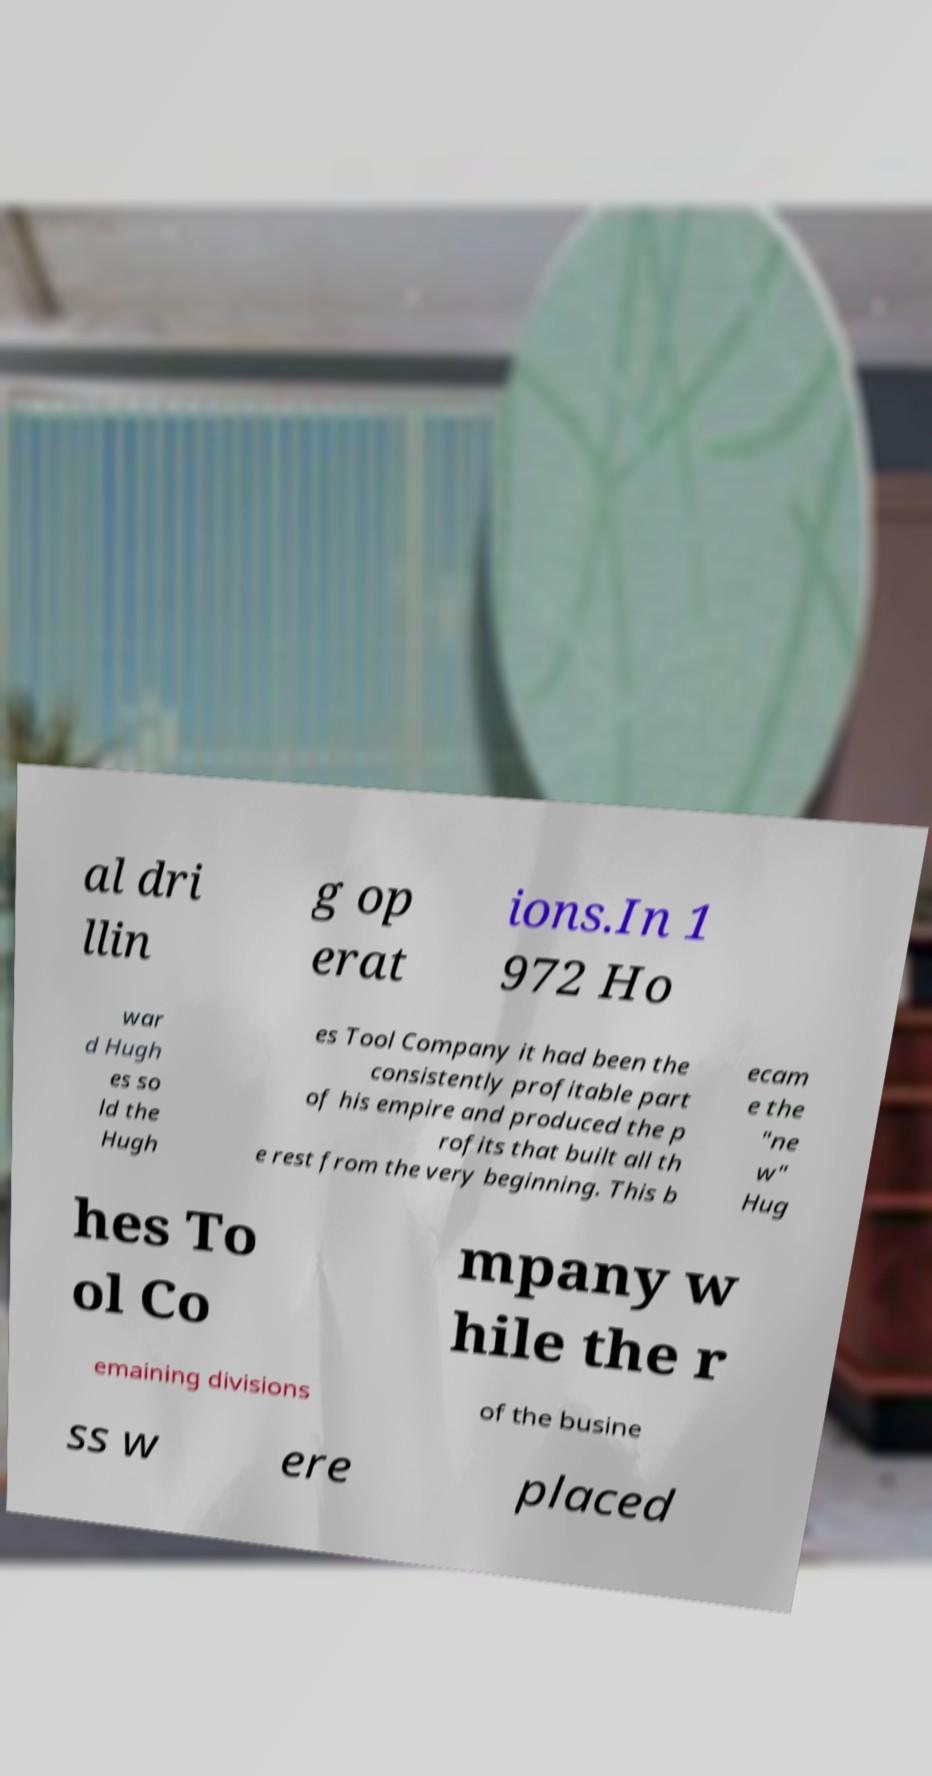Please read and relay the text visible in this image. What does it say? al dri llin g op erat ions.In 1 972 Ho war d Hugh es so ld the Hugh es Tool Company it had been the consistently profitable part of his empire and produced the p rofits that built all th e rest from the very beginning. This b ecam e the "ne w" Hug hes To ol Co mpany w hile the r emaining divisions of the busine ss w ere placed 